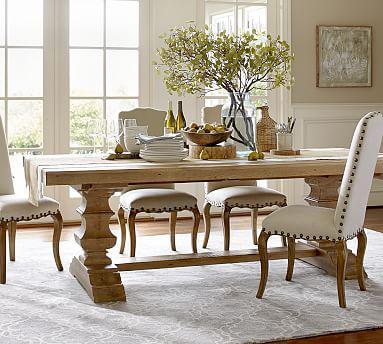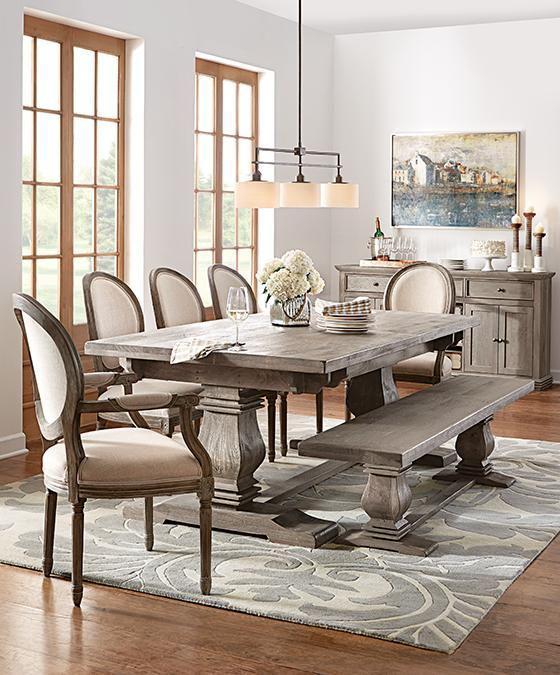The first image is the image on the left, the second image is the image on the right. For the images displayed, is the sentence "An image shows a pedestal table flanked by a long bench on one side and pale neutral fabric-covered chairs on the other side." factually correct? Answer yes or no. Yes. The first image is the image on the left, the second image is the image on the right. Assess this claim about the two images: "A plant is sitting on the table in the image on the left.". Correct or not? Answer yes or no. Yes. 